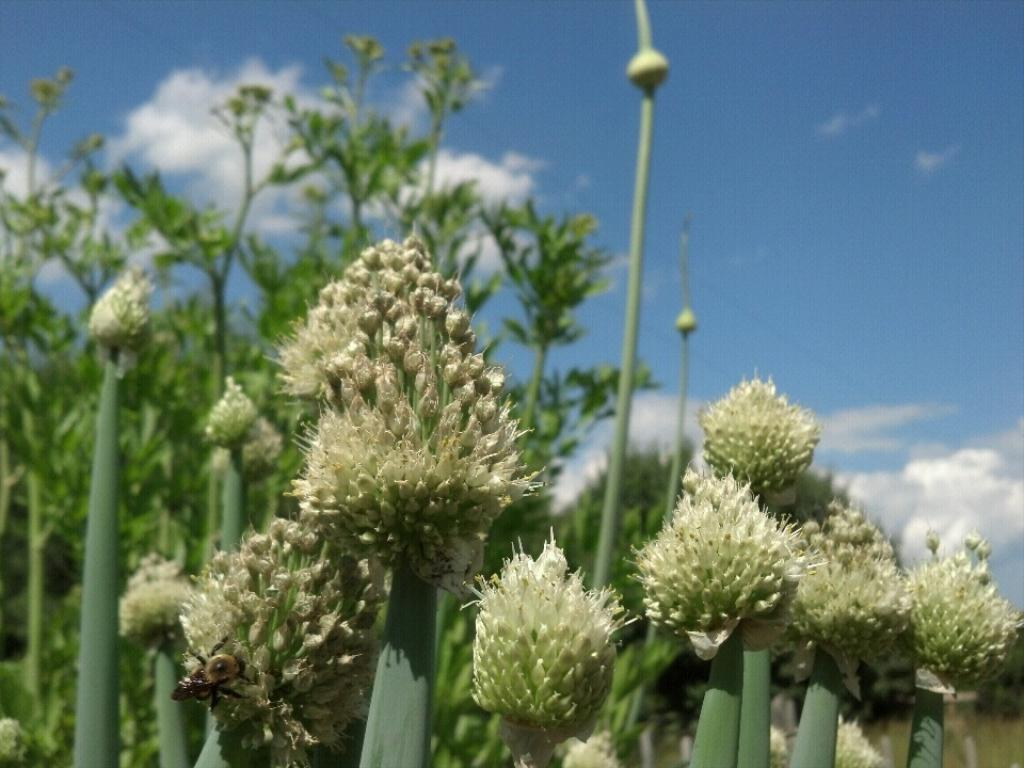What type of vegetation can be seen in the image? There are plants in the front of the image. What part of the natural environment is visible in the image? The sky is visible in the background of the image. What type of apparel is being worn by the nation in the image? There is no nation or apparel present in the image; it features plants and sky. What type of alarm can be heard in the image? There is no alarm present in the image, as it is a still image and does not contain any sounds. 